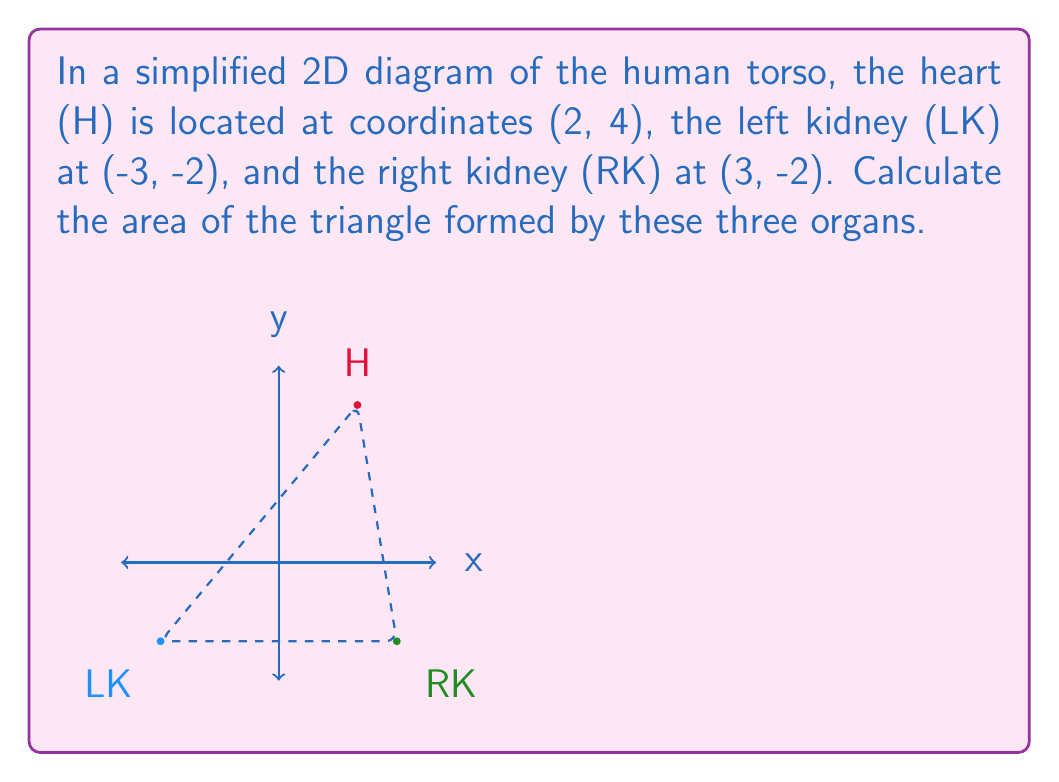Show me your answer to this math problem. To calculate the area of the triangle, we can use the formula:

$$ A = \frac{1}{2}|x_1(y_2 - y_3) + x_2(y_3 - y_1) + x_3(y_1 - y_2)| $$

Where $(x_1, y_1)$, $(x_2, y_2)$, and $(x_3, y_3)$ are the coordinates of the three points.

Let's assign:
$(x_1, y_1) = (2, 4)$ for the heart
$(x_2, y_2) = (-3, -2)$ for the left kidney
$(x_3, y_3) = (3, -2)$ for the right kidney

Substituting into the formula:

$$ A = \frac{1}{2}|2(-2 - (-2)) + (-3)((-2) - 4) + 3(4 - (-2))| $$

$$ A = \frac{1}{2}|2(0) + (-3)(-6) + 3(6)| $$

$$ A = \frac{1}{2}|0 + 18 + 18| $$

$$ A = \frac{1}{2}(36) = 18 $$

Therefore, the area of the triangle is 18 square units.
Answer: 18 square units 